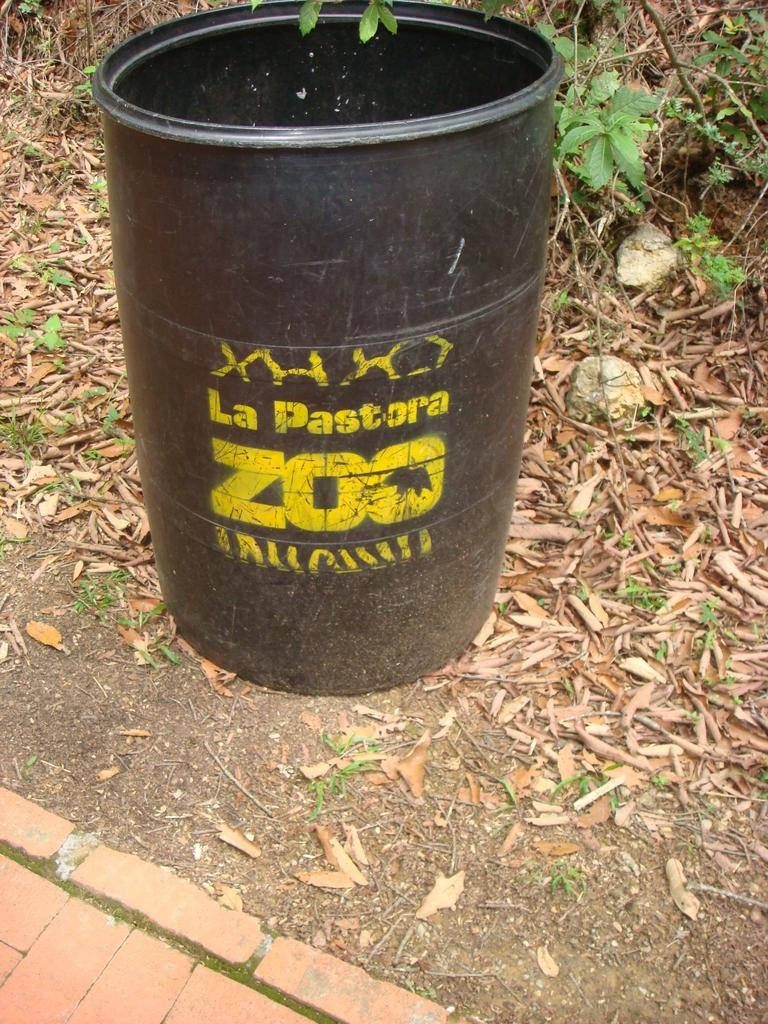Provide a one-sentence caption for the provided image. The black and yellow barrel is from La Pastora Zoo. 